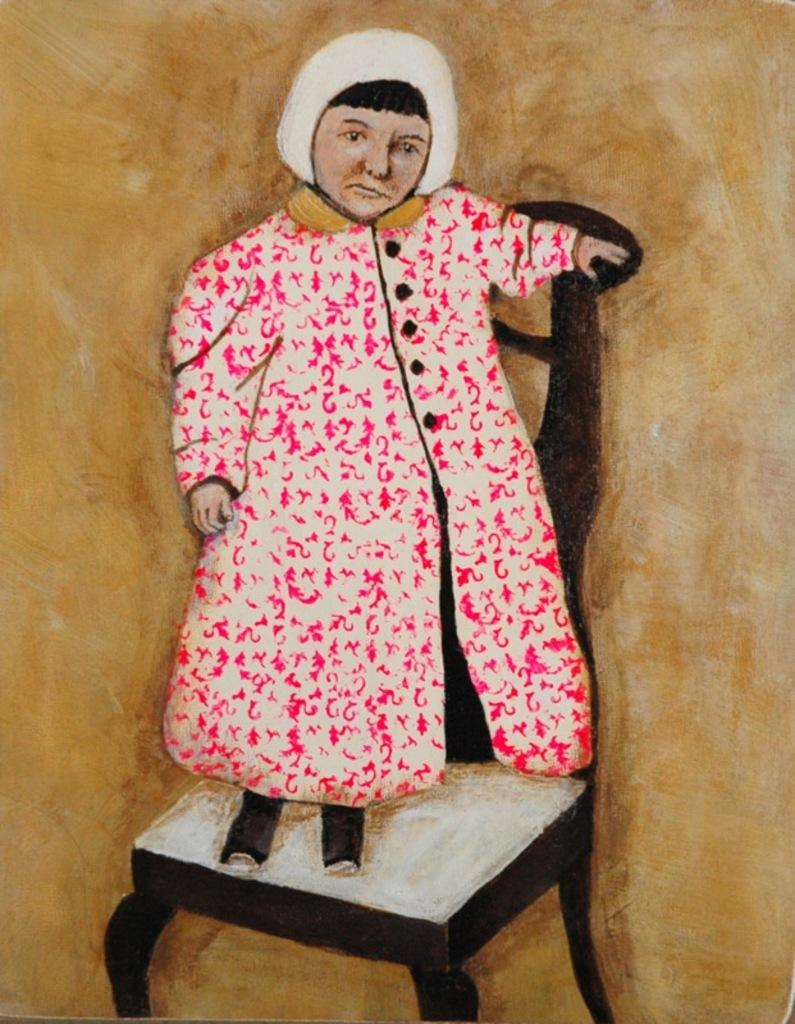What is depicted in the painting in the image? There is a painting of a person in the image. What is the person in the painting doing? The person in the painting is standing on a chair. What color is the background of the image? The background of the image is brown. What sound can be heard coming from the middle of the painting? There is no sound present in the image, as it is a painting of a person standing on a chair with a brown background. 